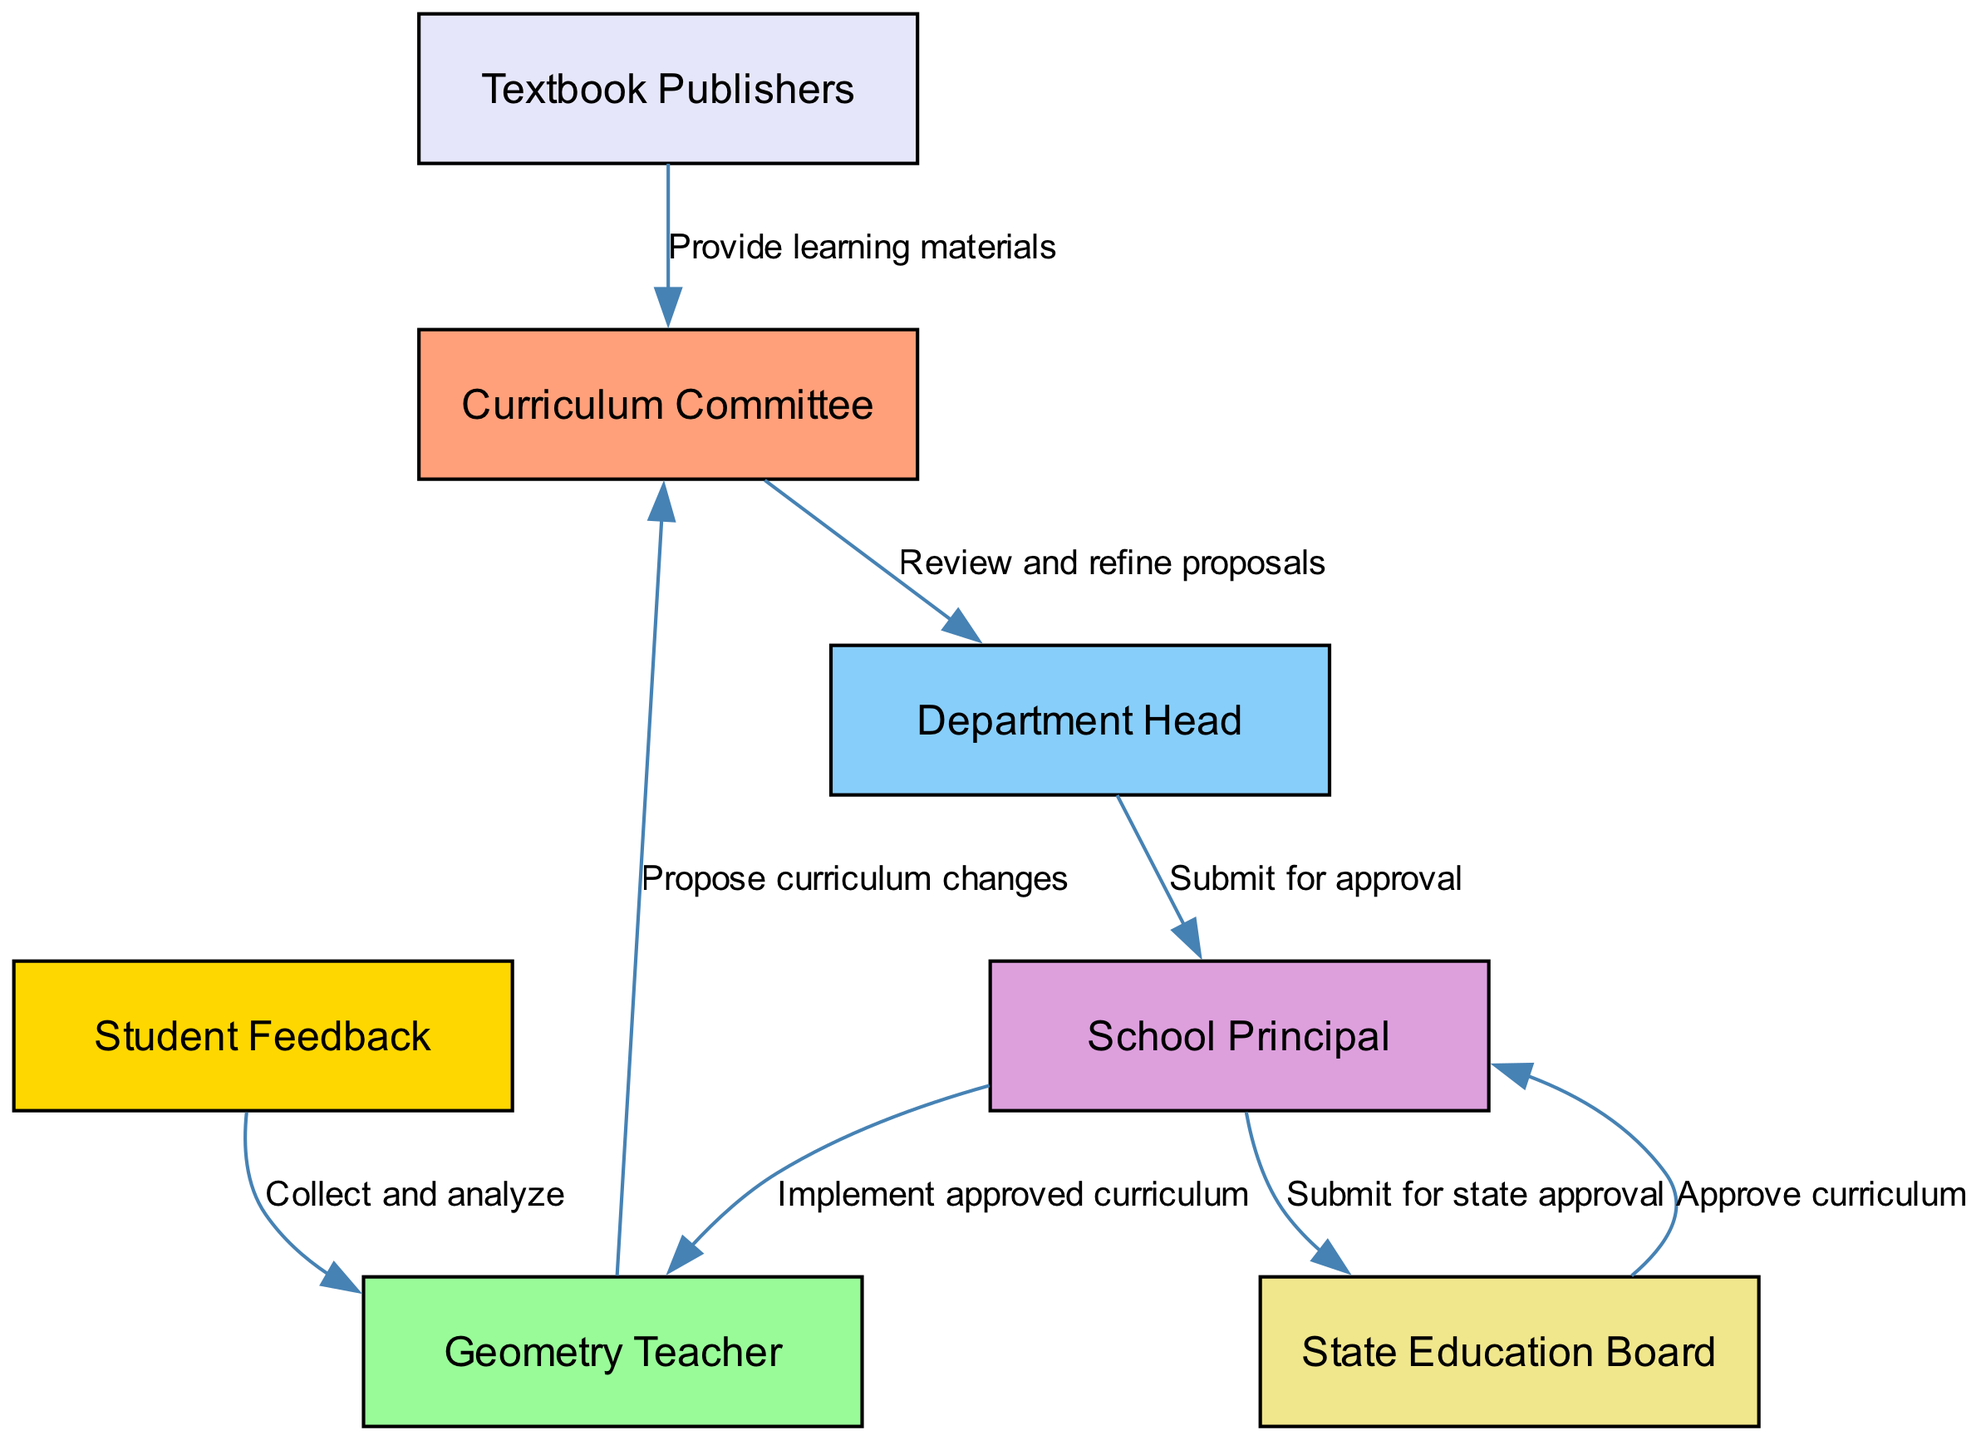What is the final node in the diagram? The final node denotes the end of the flow, which in this case is where the approved curriculum is implemented, represented by the node "Geometry Teacher."
Answer: Geometry Teacher How many nodes are present in the diagram? By counting all the distinct entities shown in the diagram, we find that there are a total of seven nodes listed: Curriculum Committee, Geometry Teacher, Department Head, School Principal, State Education Board, Textbook Publishers, and Student Feedback.
Answer: Seven Which node submits the curriculum for state approval? The node that submits the curriculum for state approval is identified as "School Principal," which is the intermediary between the school and the education board.
Answer: School Principal What label describes the relationship between the Geometry Teacher and the Curriculum Committee? The relationship is described by the label "Propose curriculum changes," indicating that the Geometry Teacher initiates changes by proposing them to the Curriculum Committee.
Answer: Propose curriculum changes Which entity provides learning materials? The node that provides learning materials is "Textbook Publishers," which connects to the Curriculum Committee by supplying the necessary resources for the curriculum.
Answer: Textbook Publishers What action follows the approval of the curriculum by the State Education Board? After the curriculum is approved, the action that follows is described by the label "Implement approved curriculum," which the School Principal communicates to the Geometry Teacher.
Answer: Implement approved curriculum How many edges are present in the diagram? By examining the connections between nodes, we count a total of eight directed edges, which represent the relationships and actions between the nodes.
Answer: Eight Which node collects and analyzes student feedback? The node responsible for collecting and analyzing student feedback is labeled "Student Feedback," which interacts with the Geometry Teacher after feedback is gathered from students.
Answer: Student Feedback What is the second step in the curriculum approval process after curriculum changes are proposed? The second step is represented by the action where the "Curriculum Committee" reviews and refines proposals received from the Geometry Teacher before moving up the chain.
Answer: Review and refine proposals 